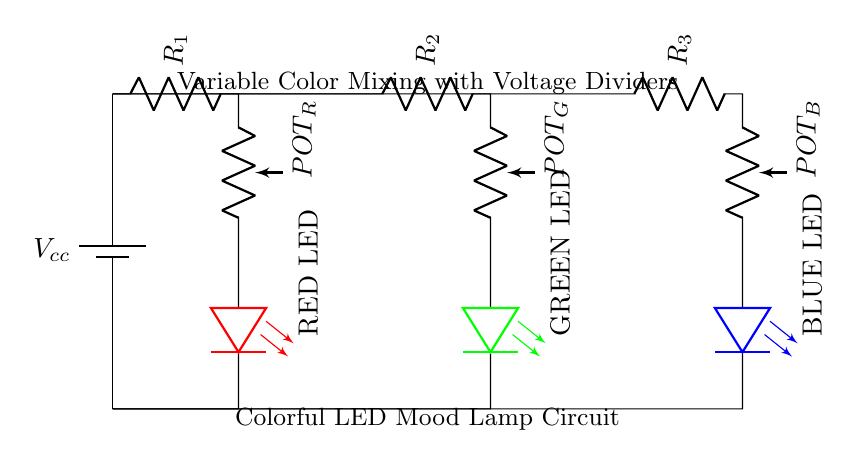What types of components are used in this circuit? The circuit contains a battery, resistors, potentiometers, and LEDs, which are all basic circuit components.
Answer: battery, resistors, potentiometers, LEDs How many potentiometers are present in the circuit? There are three different color branches: red, green, and blue, each with one potentiometer used for controlling their respective color intensity.
Answer: 3 What color LED is controlled by the first potentiometer in the circuit? The first potentiometer is linked to the red LED branch, meaning it controls the intensity of the red LED.
Answer: red How do the potentiometers affect the LED brightness? The potentiometers act as voltage dividers, adjusting the voltage supplied to each LED, which in turn changes their brightness according to the set resistance.
Answer: by adjusting voltage What is the function of the resistors in the circuit? The resistors limit the current flowing to each LED, preventing excess current that could damage them, while also working with the potentiometers in the voltage divider formation.
Answer: current limiting What happens if a potentiometer is set to its minimum resistance? When set to minimum resistance, the corresponding LED would receive the maximum voltage, likely making it very bright, while other LEDs might dim depending on their settings.
Answer: maximum brightness What is the purpose of the battery in this circuit? The battery provides the necessary voltage and current to power the circuit and allow the LEDs to light up.
Answer: power supply 